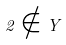<formula> <loc_0><loc_0><loc_500><loc_500>2 \notin Y</formula> 